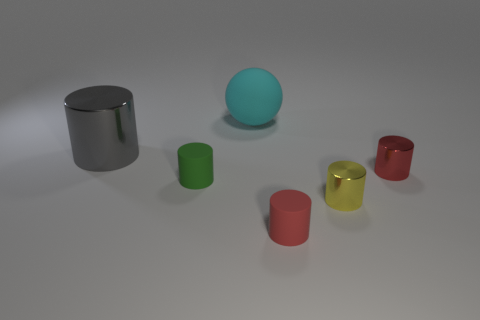Subtract all red rubber cylinders. How many cylinders are left? 4 Subtract all yellow cylinders. How many cylinders are left? 4 Subtract all purple cylinders. Subtract all cyan cubes. How many cylinders are left? 5 Add 2 green matte cylinders. How many objects exist? 8 Subtract all cylinders. How many objects are left? 1 Add 3 small blue cylinders. How many small blue cylinders exist? 3 Subtract 1 green cylinders. How many objects are left? 5 Subtract all big rubber cylinders. Subtract all cylinders. How many objects are left? 1 Add 3 tiny red matte objects. How many tiny red matte objects are left? 4 